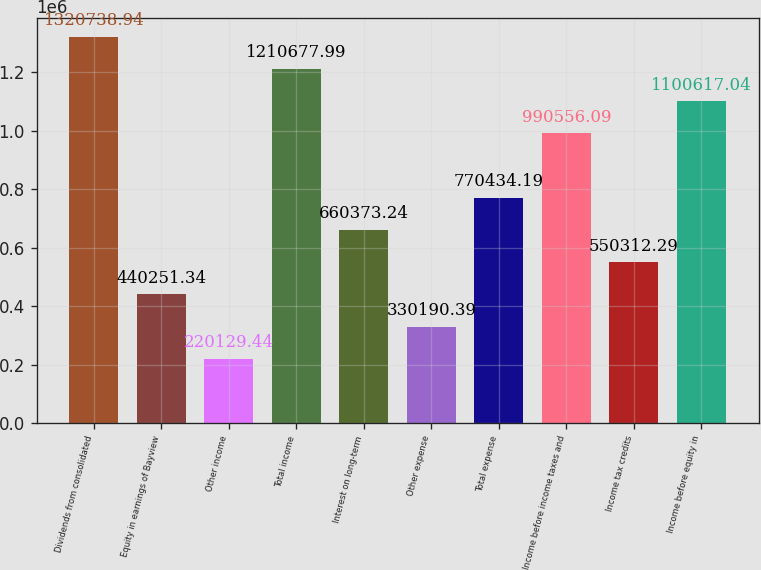Convert chart to OTSL. <chart><loc_0><loc_0><loc_500><loc_500><bar_chart><fcel>Dividends from consolidated<fcel>Equity in earnings of Bayview<fcel>Other income<fcel>Total income<fcel>Interest on long-term<fcel>Other expense<fcel>Total expense<fcel>Income before income taxes and<fcel>Income tax credits<fcel>Income before equity in<nl><fcel>1.32074e+06<fcel>440251<fcel>220129<fcel>1.21068e+06<fcel>660373<fcel>330190<fcel>770434<fcel>990556<fcel>550312<fcel>1.10062e+06<nl></chart> 